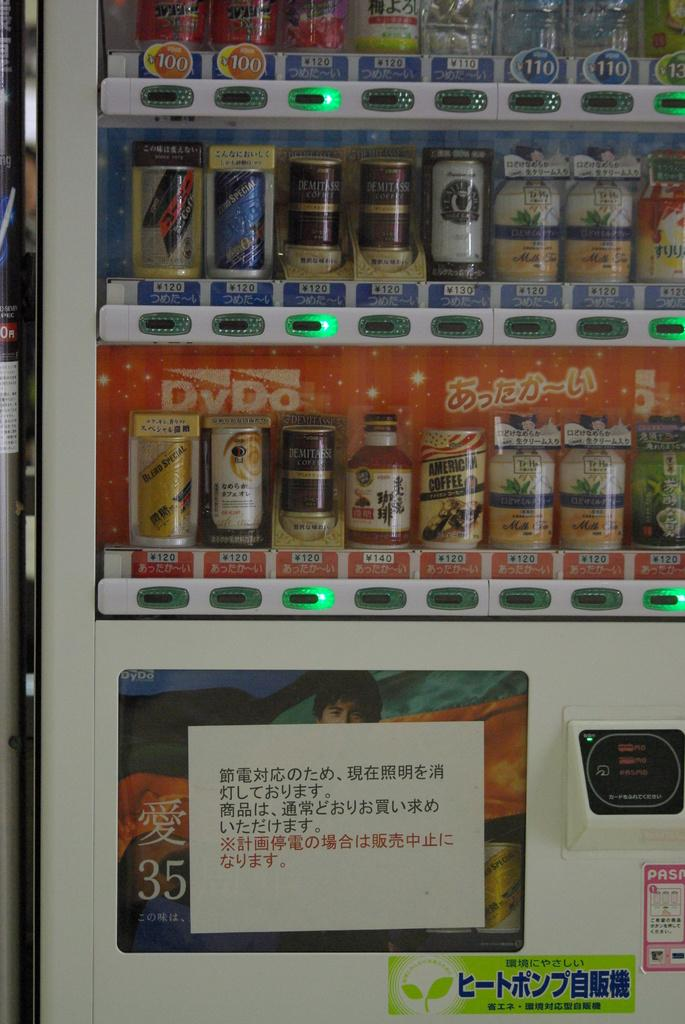Provide a one-sentence caption for the provided image. A soda machine with a lot of foreign writing on it with drinks costing 100 and 110. 